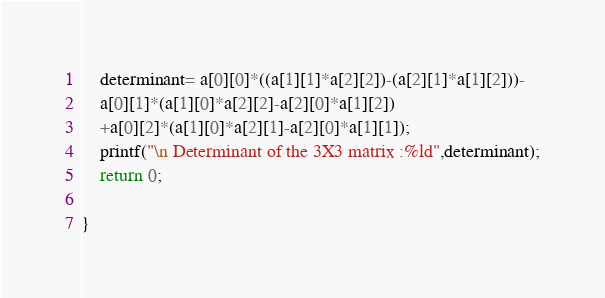Convert code to text. <code><loc_0><loc_0><loc_500><loc_500><_C_>    determinant= a[0][0]*((a[1][1]*a[2][2])-(a[2][1]*a[1][2]))-
    a[0][1]*(a[1][0]*a[2][2]-a[2][0]*a[1][2])
    +a[0][2]*(a[1][0]*a[2][1]-a[2][0]*a[1][1]);
    printf("\n Determinant of the 3X3 matrix :%ld",determinant);
    return 0;

}
</code> 